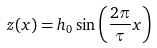<formula> <loc_0><loc_0><loc_500><loc_500>z ( x ) = h _ { 0 } \sin \left ( \frac { 2 \pi } { \tau } x \right )</formula> 